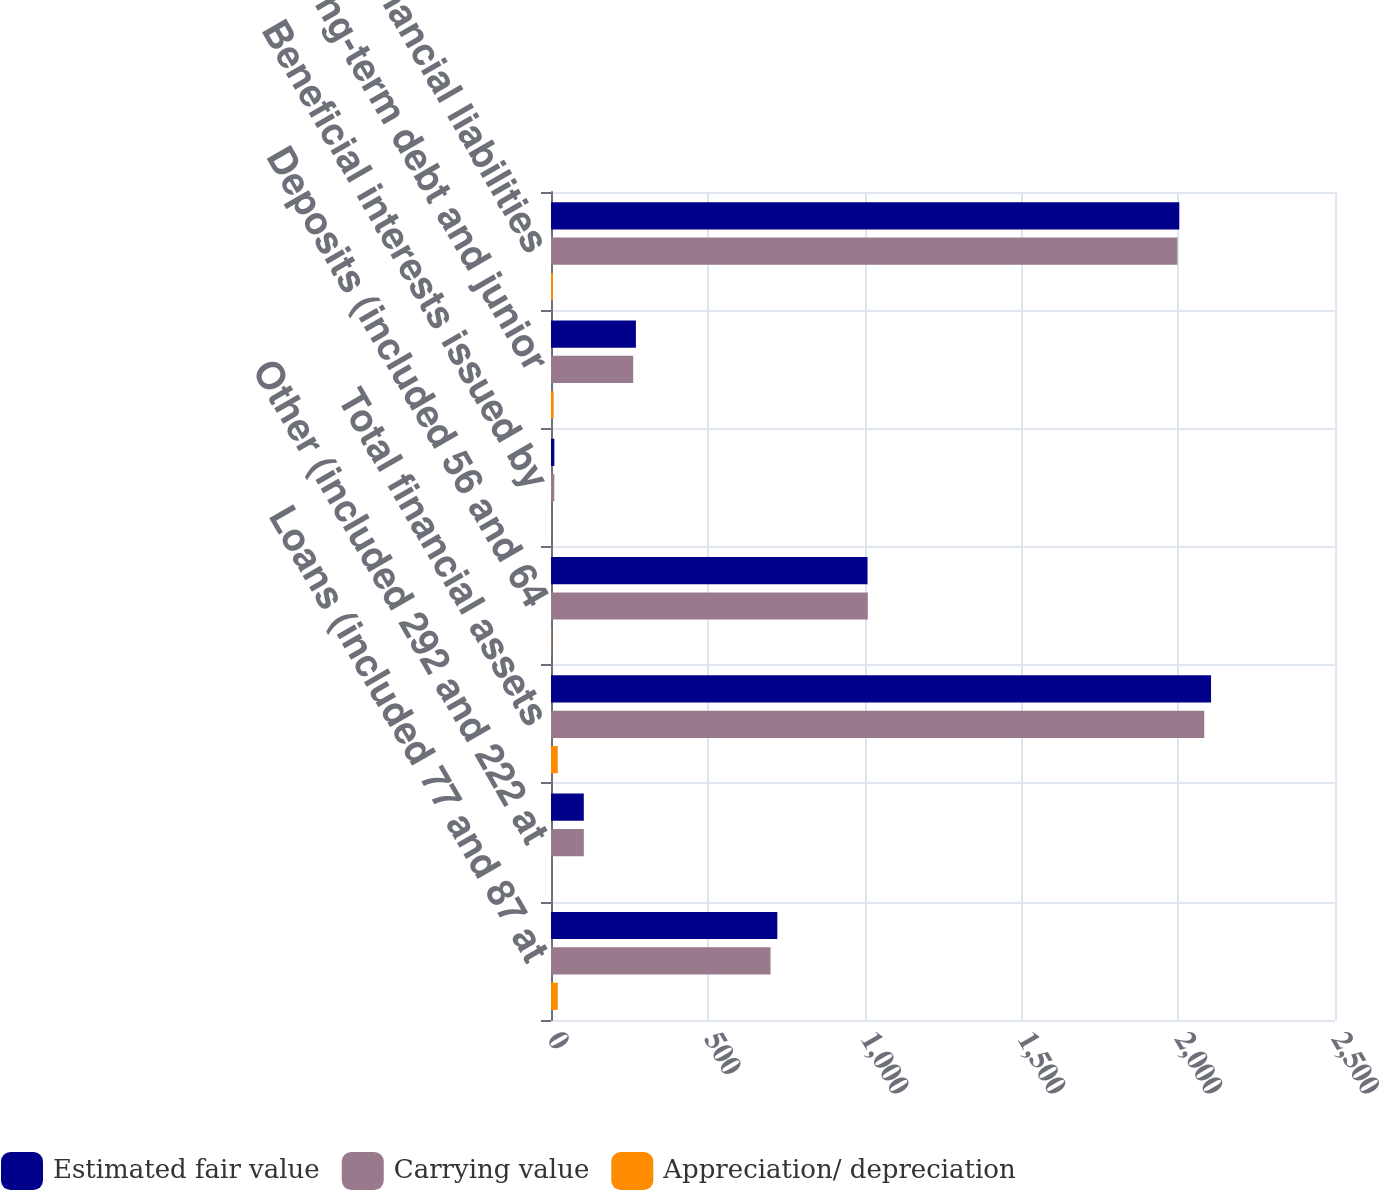<chart> <loc_0><loc_0><loc_500><loc_500><stacked_bar_chart><ecel><fcel>Loans (included 77 and 87 at<fcel>Other (included 292 and 222 at<fcel>Total financial assets<fcel>Deposits (included 56 and 64<fcel>Beneficial interests issued by<fcel>Long-term debt and junior<fcel>Total financial liabilities<nl><fcel>Estimated fair value<fcel>721.7<fcel>104.6<fcel>2104.7<fcel>1009.3<fcel>10.6<fcel>270.7<fcel>2003.5<nl><fcel>Carrying value<fcel>700<fcel>104.7<fcel>2083.1<fcel>1010.2<fcel>10.5<fcel>262.1<fcel>1997.4<nl><fcel>Appreciation/ depreciation<fcel>21.7<fcel>0.1<fcel>21.6<fcel>0.9<fcel>0.1<fcel>8.6<fcel>6.1<nl></chart> 